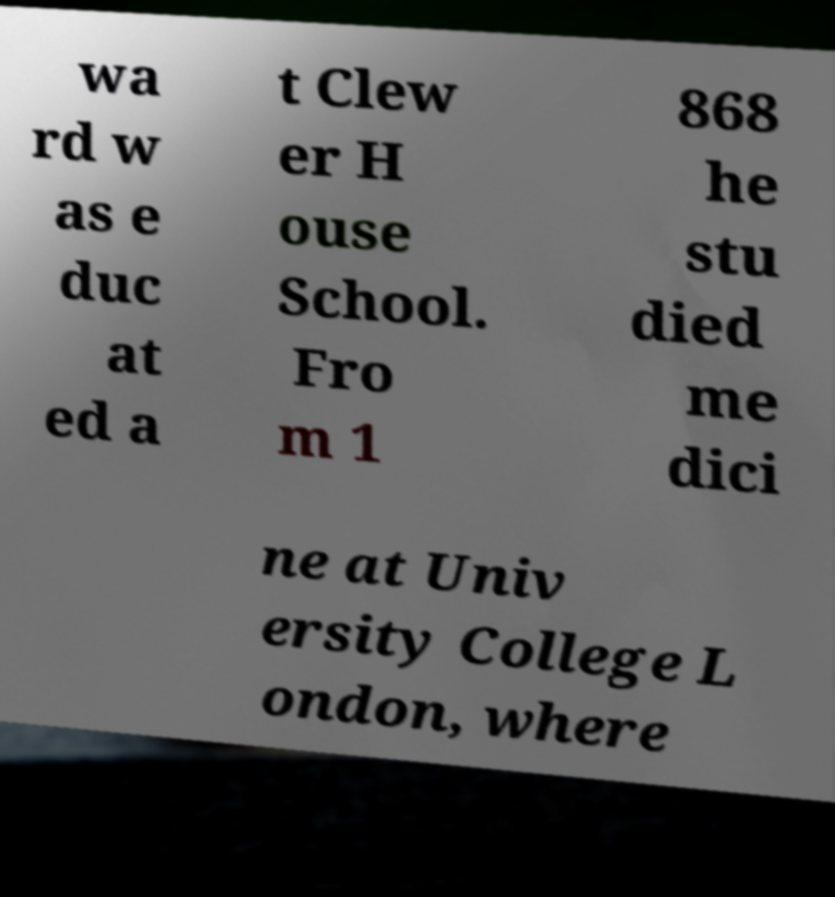Please read and relay the text visible in this image. What does it say? wa rd w as e duc at ed a t Clew er H ouse School. Fro m 1 868 he stu died me dici ne at Univ ersity College L ondon, where 